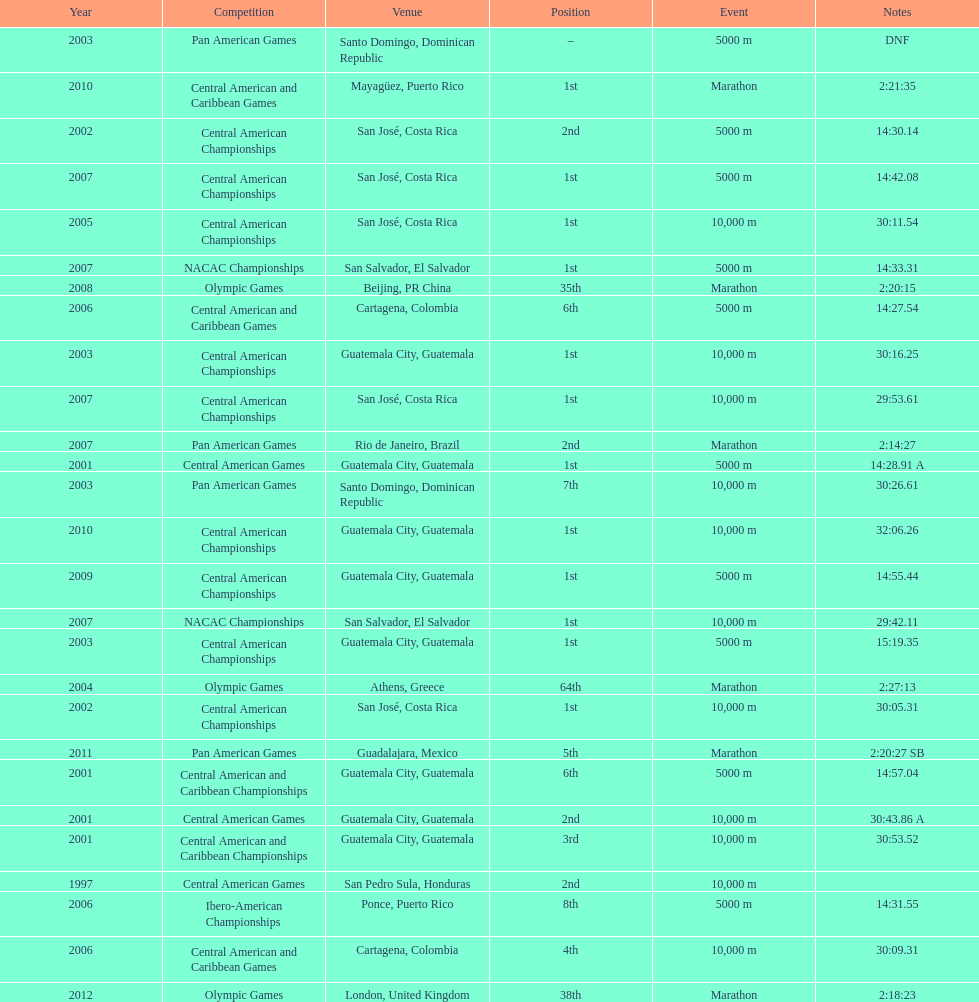Tell me the number of times they competed in guatamala. 5. 